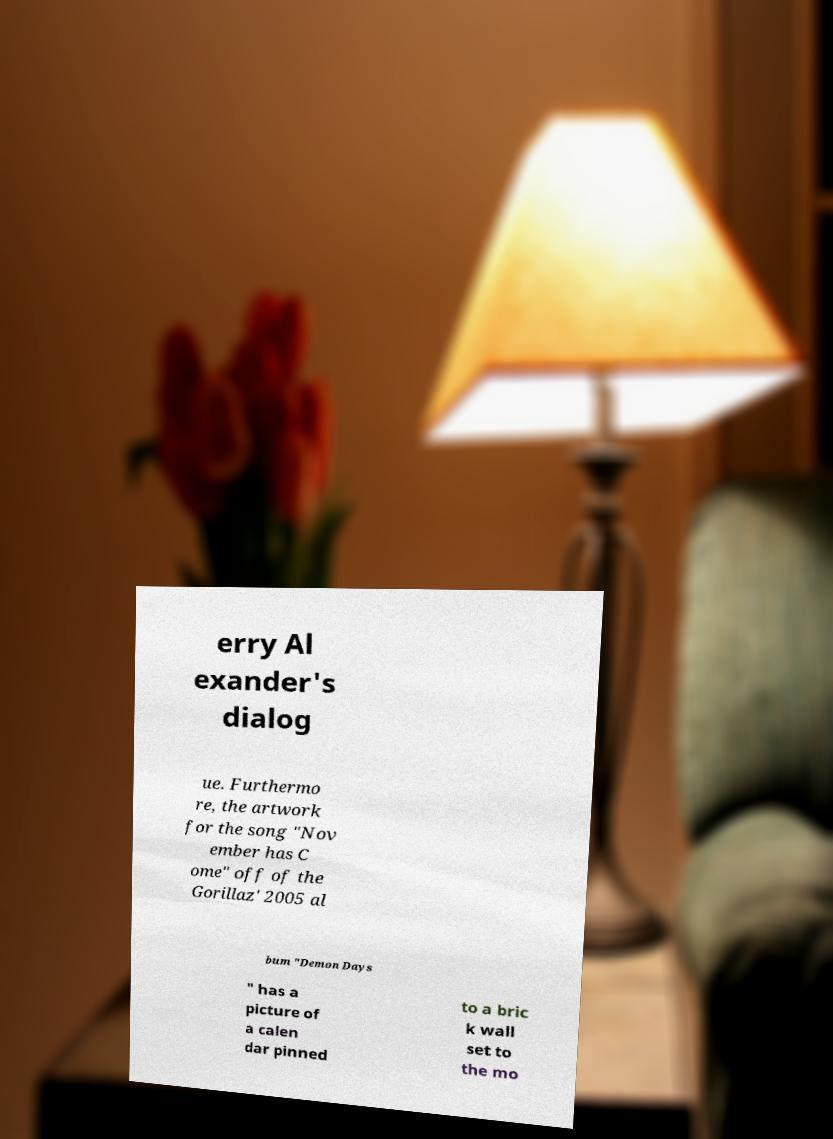For documentation purposes, I need the text within this image transcribed. Could you provide that? erry Al exander's dialog ue. Furthermo re, the artwork for the song "Nov ember has C ome" off of the Gorillaz' 2005 al bum "Demon Days " has a picture of a calen dar pinned to a bric k wall set to the mo 